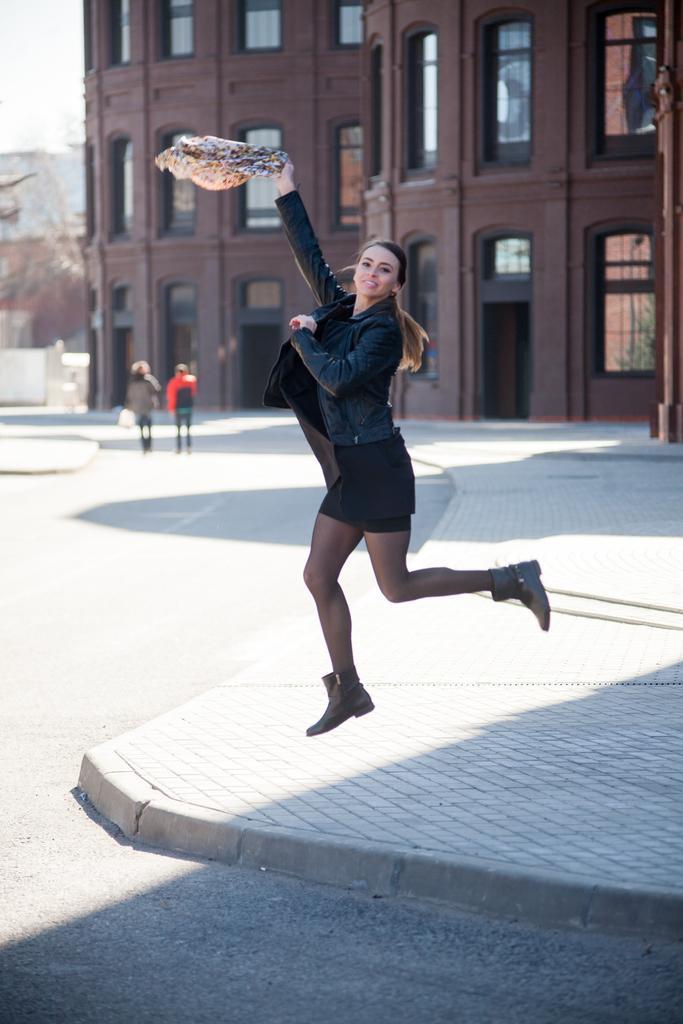In one or two sentences, can you explain what this image depicts? In this image we can see a women wearing shoes and holding a object in her right hand. And behind we can see buildings with many windows. And in the background we can see two persons. And on the right side we can see poles. And at the bottom we can see ground. 